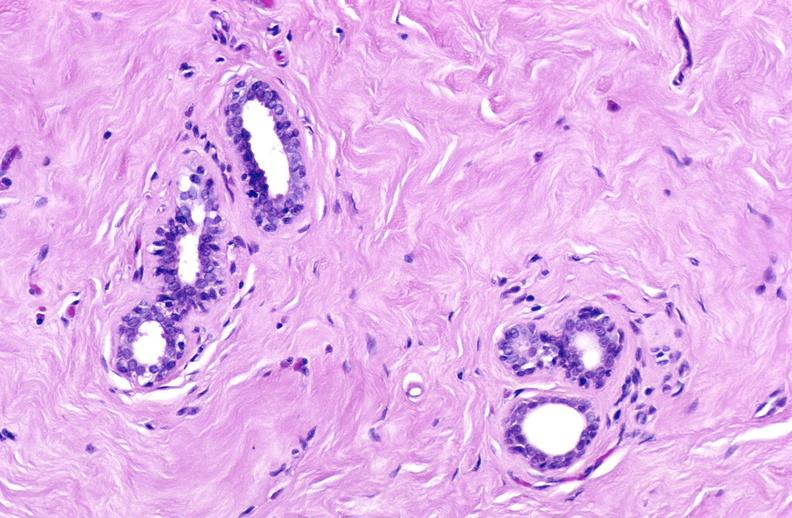does breast show breast, fibroadenoma?
Answer the question using a single word or phrase. No 